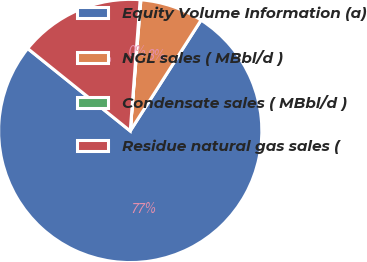Convert chart. <chart><loc_0><loc_0><loc_500><loc_500><pie_chart><fcel>Equity Volume Information (a)<fcel>NGL sales ( MBbl/d )<fcel>Condensate sales ( MBbl/d )<fcel>Residue natural gas sales (<nl><fcel>76.73%<fcel>7.76%<fcel>0.09%<fcel>15.42%<nl></chart> 